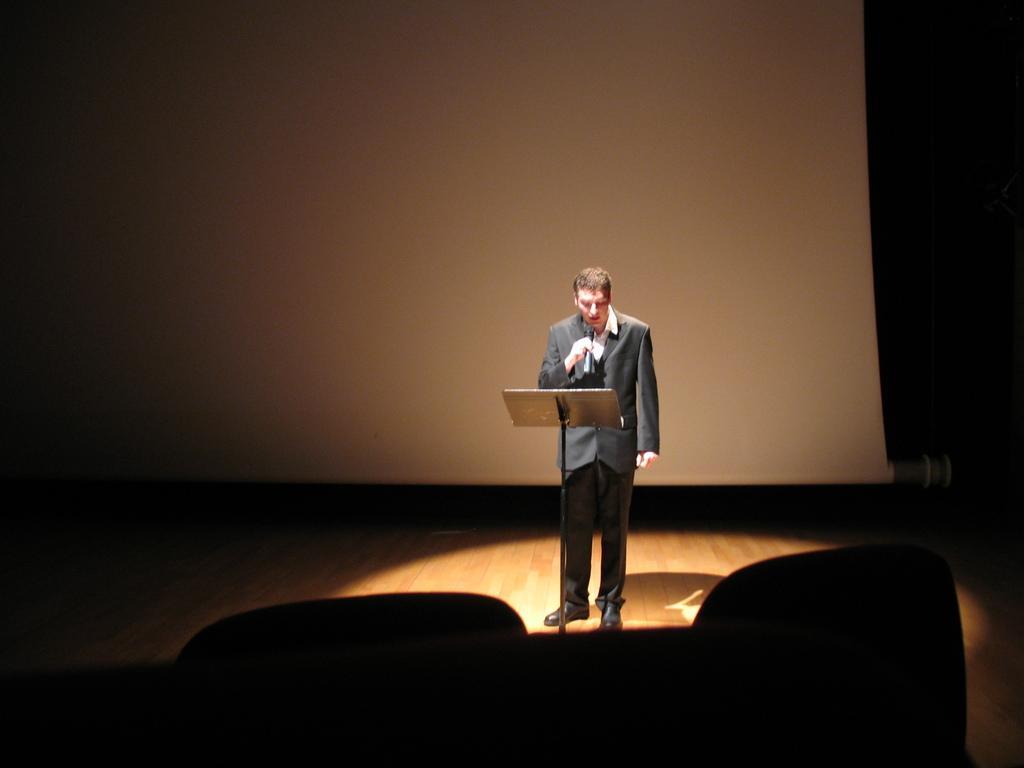In one or two sentences, can you explain what this image depicts? In this picture is a man standing on the dais and he is wearing a blazer, holding a microphone and there is a book placed in front of him and in the backdrop there is a screen and it is dark around him. 